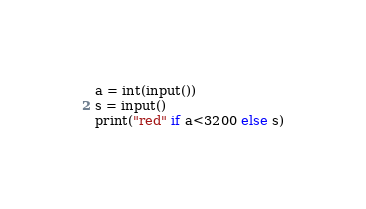Convert code to text. <code><loc_0><loc_0><loc_500><loc_500><_Python_>a = int(input())
s = input()
print("red" if a<3200 else s)</code> 